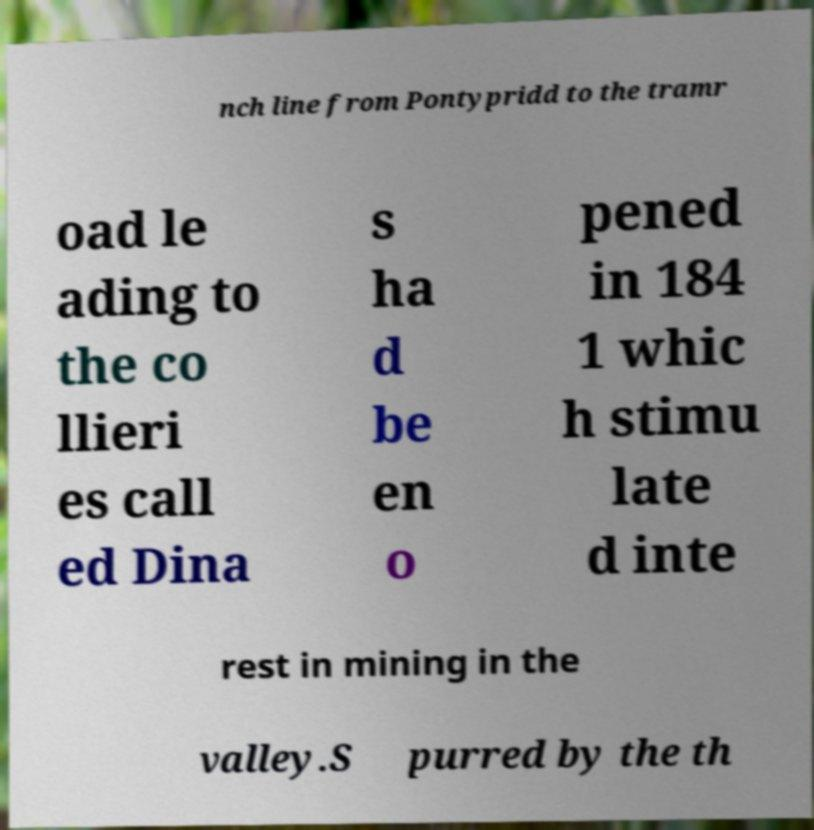Can you read and provide the text displayed in the image?This photo seems to have some interesting text. Can you extract and type it out for me? nch line from Pontypridd to the tramr oad le ading to the co llieri es call ed Dina s ha d be en o pened in 184 1 whic h stimu late d inte rest in mining in the valley.S purred by the th 